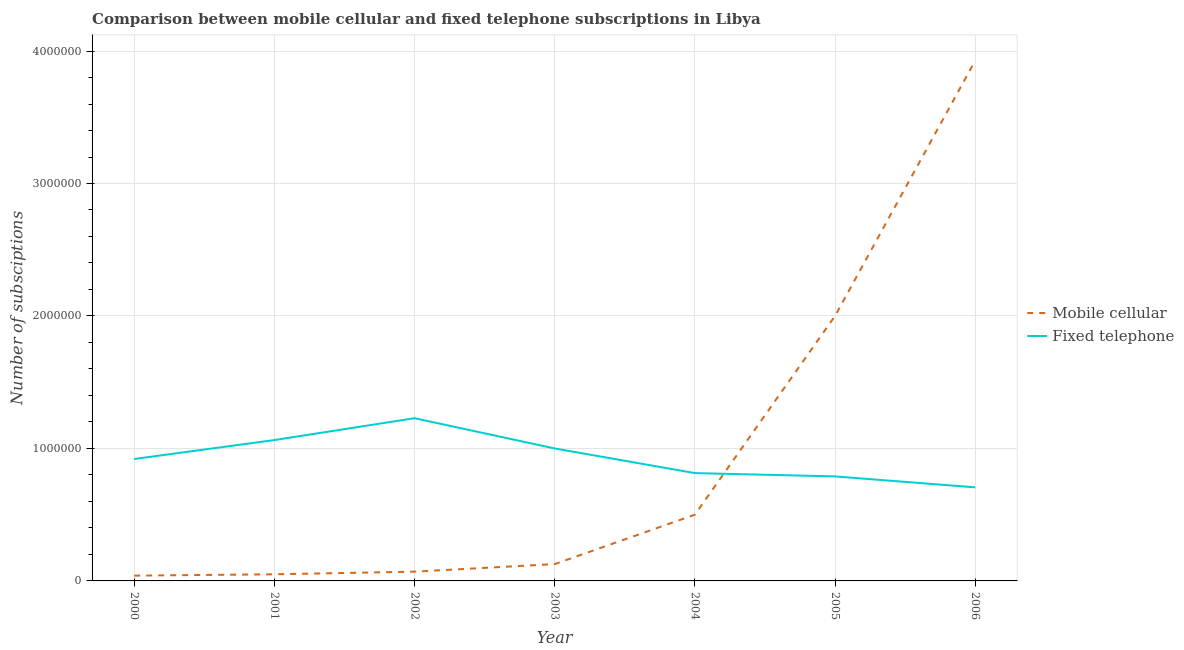What is the number of fixed telephone subscriptions in 2000?
Provide a succinct answer. 9.20e+05. Across all years, what is the maximum number of fixed telephone subscriptions?
Give a very brief answer. 1.23e+06. Across all years, what is the minimum number of fixed telephone subscriptions?
Make the answer very short. 7.06e+05. In which year was the number of fixed telephone subscriptions maximum?
Offer a terse response. 2002. In which year was the number of fixed telephone subscriptions minimum?
Make the answer very short. 2006. What is the total number of mobile cellular subscriptions in the graph?
Make the answer very short. 6.71e+06. What is the difference between the number of mobile cellular subscriptions in 2001 and that in 2004?
Make the answer very short. -4.50e+05. What is the difference between the number of fixed telephone subscriptions in 2004 and the number of mobile cellular subscriptions in 2000?
Offer a terse response. 7.74e+05. What is the average number of fixed telephone subscriptions per year?
Make the answer very short. 9.32e+05. In the year 2002, what is the difference between the number of fixed telephone subscriptions and number of mobile cellular subscriptions?
Your answer should be very brief. 1.16e+06. What is the ratio of the number of mobile cellular subscriptions in 2000 to that in 2002?
Keep it short and to the point. 0.57. What is the difference between the highest and the second highest number of mobile cellular subscriptions?
Provide a succinct answer. 1.93e+06. What is the difference between the highest and the lowest number of mobile cellular subscriptions?
Provide a succinct answer. 3.89e+06. Is the sum of the number of fixed telephone subscriptions in 2005 and 2006 greater than the maximum number of mobile cellular subscriptions across all years?
Keep it short and to the point. No. Is the number of mobile cellular subscriptions strictly less than the number of fixed telephone subscriptions over the years?
Your response must be concise. No. What is the difference between two consecutive major ticks on the Y-axis?
Ensure brevity in your answer.  1.00e+06. Are the values on the major ticks of Y-axis written in scientific E-notation?
Provide a short and direct response. No. Where does the legend appear in the graph?
Make the answer very short. Center right. How are the legend labels stacked?
Give a very brief answer. Vertical. What is the title of the graph?
Offer a terse response. Comparison between mobile cellular and fixed telephone subscriptions in Libya. What is the label or title of the Y-axis?
Ensure brevity in your answer.  Number of subsciptions. What is the Number of subsciptions of Mobile cellular in 2000?
Ensure brevity in your answer.  4.00e+04. What is the Number of subsciptions in Fixed telephone in 2000?
Provide a succinct answer. 9.20e+05. What is the Number of subsciptions of Fixed telephone in 2001?
Keep it short and to the point. 1.06e+06. What is the Number of subsciptions of Fixed telephone in 2002?
Provide a short and direct response. 1.23e+06. What is the Number of subsciptions in Mobile cellular in 2003?
Offer a terse response. 1.27e+05. What is the Number of subsciptions of Fixed telephone in 2003?
Your answer should be compact. 1.00e+06. What is the Number of subsciptions of Fixed telephone in 2004?
Provide a short and direct response. 8.14e+05. What is the Number of subsciptions in Fixed telephone in 2005?
Your answer should be very brief. 7.89e+05. What is the Number of subsciptions in Mobile cellular in 2006?
Ensure brevity in your answer.  3.93e+06. What is the Number of subsciptions of Fixed telephone in 2006?
Keep it short and to the point. 7.06e+05. Across all years, what is the maximum Number of subsciptions in Mobile cellular?
Your answer should be compact. 3.93e+06. Across all years, what is the maximum Number of subsciptions of Fixed telephone?
Keep it short and to the point. 1.23e+06. Across all years, what is the minimum Number of subsciptions of Fixed telephone?
Provide a succinct answer. 7.06e+05. What is the total Number of subsciptions in Mobile cellular in the graph?
Give a very brief answer. 6.71e+06. What is the total Number of subsciptions in Fixed telephone in the graph?
Ensure brevity in your answer.  6.52e+06. What is the difference between the Number of subsciptions of Mobile cellular in 2000 and that in 2001?
Make the answer very short. -10000. What is the difference between the Number of subsciptions in Fixed telephone in 2000 and that in 2001?
Keep it short and to the point. -1.43e+05. What is the difference between the Number of subsciptions of Fixed telephone in 2000 and that in 2002?
Offer a very short reply. -3.08e+05. What is the difference between the Number of subsciptions in Mobile cellular in 2000 and that in 2003?
Offer a terse response. -8.70e+04. What is the difference between the Number of subsciptions of Fixed telephone in 2000 and that in 2003?
Offer a terse response. -7.96e+04. What is the difference between the Number of subsciptions of Mobile cellular in 2000 and that in 2004?
Offer a very short reply. -4.60e+05. What is the difference between the Number of subsciptions of Fixed telephone in 2000 and that in 2004?
Ensure brevity in your answer.  1.06e+05. What is the difference between the Number of subsciptions in Mobile cellular in 2000 and that in 2005?
Provide a short and direct response. -1.96e+06. What is the difference between the Number of subsciptions of Fixed telephone in 2000 and that in 2005?
Offer a terse response. 1.31e+05. What is the difference between the Number of subsciptions in Mobile cellular in 2000 and that in 2006?
Provide a short and direct response. -3.89e+06. What is the difference between the Number of subsciptions in Fixed telephone in 2000 and that in 2006?
Offer a very short reply. 2.14e+05. What is the difference between the Number of subsciptions of Mobile cellular in 2001 and that in 2002?
Ensure brevity in your answer.  -2.00e+04. What is the difference between the Number of subsciptions in Fixed telephone in 2001 and that in 2002?
Offer a terse response. -1.65e+05. What is the difference between the Number of subsciptions in Mobile cellular in 2001 and that in 2003?
Your response must be concise. -7.70e+04. What is the difference between the Number of subsciptions of Fixed telephone in 2001 and that in 2003?
Offer a terse response. 6.33e+04. What is the difference between the Number of subsciptions in Mobile cellular in 2001 and that in 2004?
Your response must be concise. -4.50e+05. What is the difference between the Number of subsciptions of Fixed telephone in 2001 and that in 2004?
Your response must be concise. 2.49e+05. What is the difference between the Number of subsciptions in Mobile cellular in 2001 and that in 2005?
Keep it short and to the point. -1.95e+06. What is the difference between the Number of subsciptions of Fixed telephone in 2001 and that in 2005?
Keep it short and to the point. 2.74e+05. What is the difference between the Number of subsciptions in Mobile cellular in 2001 and that in 2006?
Offer a terse response. -3.88e+06. What is the difference between the Number of subsciptions in Fixed telephone in 2001 and that in 2006?
Provide a short and direct response. 3.57e+05. What is the difference between the Number of subsciptions in Mobile cellular in 2002 and that in 2003?
Provide a short and direct response. -5.70e+04. What is the difference between the Number of subsciptions in Fixed telephone in 2002 and that in 2003?
Provide a short and direct response. 2.28e+05. What is the difference between the Number of subsciptions of Mobile cellular in 2002 and that in 2004?
Ensure brevity in your answer.  -4.30e+05. What is the difference between the Number of subsciptions in Fixed telephone in 2002 and that in 2004?
Give a very brief answer. 4.14e+05. What is the difference between the Number of subsciptions of Mobile cellular in 2002 and that in 2005?
Your response must be concise. -1.93e+06. What is the difference between the Number of subsciptions of Fixed telephone in 2002 and that in 2005?
Keep it short and to the point. 4.39e+05. What is the difference between the Number of subsciptions of Mobile cellular in 2002 and that in 2006?
Keep it short and to the point. -3.86e+06. What is the difference between the Number of subsciptions in Fixed telephone in 2002 and that in 2006?
Keep it short and to the point. 5.22e+05. What is the difference between the Number of subsciptions of Mobile cellular in 2003 and that in 2004?
Your answer should be very brief. -3.73e+05. What is the difference between the Number of subsciptions of Fixed telephone in 2003 and that in 2004?
Provide a short and direct response. 1.86e+05. What is the difference between the Number of subsciptions of Mobile cellular in 2003 and that in 2005?
Make the answer very short. -1.87e+06. What is the difference between the Number of subsciptions of Fixed telephone in 2003 and that in 2005?
Your response must be concise. 2.11e+05. What is the difference between the Number of subsciptions of Mobile cellular in 2003 and that in 2006?
Your answer should be compact. -3.80e+06. What is the difference between the Number of subsciptions in Fixed telephone in 2003 and that in 2006?
Offer a very short reply. 2.94e+05. What is the difference between the Number of subsciptions of Mobile cellular in 2004 and that in 2005?
Provide a succinct answer. -1.50e+06. What is the difference between the Number of subsciptions of Fixed telephone in 2004 and that in 2005?
Offer a terse response. 2.50e+04. What is the difference between the Number of subsciptions in Mobile cellular in 2004 and that in 2006?
Keep it short and to the point. -3.43e+06. What is the difference between the Number of subsciptions in Fixed telephone in 2004 and that in 2006?
Your answer should be very brief. 1.08e+05. What is the difference between the Number of subsciptions of Mobile cellular in 2005 and that in 2006?
Make the answer very short. -1.93e+06. What is the difference between the Number of subsciptions of Fixed telephone in 2005 and that in 2006?
Keep it short and to the point. 8.26e+04. What is the difference between the Number of subsciptions in Mobile cellular in 2000 and the Number of subsciptions in Fixed telephone in 2001?
Offer a very short reply. -1.02e+06. What is the difference between the Number of subsciptions in Mobile cellular in 2000 and the Number of subsciptions in Fixed telephone in 2002?
Provide a short and direct response. -1.19e+06. What is the difference between the Number of subsciptions of Mobile cellular in 2000 and the Number of subsciptions of Fixed telephone in 2003?
Offer a terse response. -9.60e+05. What is the difference between the Number of subsciptions of Mobile cellular in 2000 and the Number of subsciptions of Fixed telephone in 2004?
Your answer should be very brief. -7.74e+05. What is the difference between the Number of subsciptions of Mobile cellular in 2000 and the Number of subsciptions of Fixed telephone in 2005?
Provide a succinct answer. -7.49e+05. What is the difference between the Number of subsciptions of Mobile cellular in 2000 and the Number of subsciptions of Fixed telephone in 2006?
Your answer should be compact. -6.66e+05. What is the difference between the Number of subsciptions of Mobile cellular in 2001 and the Number of subsciptions of Fixed telephone in 2002?
Provide a short and direct response. -1.18e+06. What is the difference between the Number of subsciptions of Mobile cellular in 2001 and the Number of subsciptions of Fixed telephone in 2003?
Your answer should be very brief. -9.50e+05. What is the difference between the Number of subsciptions of Mobile cellular in 2001 and the Number of subsciptions of Fixed telephone in 2004?
Keep it short and to the point. -7.64e+05. What is the difference between the Number of subsciptions in Mobile cellular in 2001 and the Number of subsciptions in Fixed telephone in 2005?
Offer a very short reply. -7.39e+05. What is the difference between the Number of subsciptions of Mobile cellular in 2001 and the Number of subsciptions of Fixed telephone in 2006?
Ensure brevity in your answer.  -6.56e+05. What is the difference between the Number of subsciptions in Mobile cellular in 2002 and the Number of subsciptions in Fixed telephone in 2003?
Your answer should be compact. -9.30e+05. What is the difference between the Number of subsciptions of Mobile cellular in 2002 and the Number of subsciptions of Fixed telephone in 2004?
Make the answer very short. -7.44e+05. What is the difference between the Number of subsciptions in Mobile cellular in 2002 and the Number of subsciptions in Fixed telephone in 2005?
Offer a terse response. -7.19e+05. What is the difference between the Number of subsciptions in Mobile cellular in 2002 and the Number of subsciptions in Fixed telephone in 2006?
Give a very brief answer. -6.36e+05. What is the difference between the Number of subsciptions of Mobile cellular in 2003 and the Number of subsciptions of Fixed telephone in 2004?
Provide a succinct answer. -6.87e+05. What is the difference between the Number of subsciptions of Mobile cellular in 2003 and the Number of subsciptions of Fixed telephone in 2005?
Make the answer very short. -6.62e+05. What is the difference between the Number of subsciptions of Mobile cellular in 2003 and the Number of subsciptions of Fixed telephone in 2006?
Keep it short and to the point. -5.79e+05. What is the difference between the Number of subsciptions in Mobile cellular in 2004 and the Number of subsciptions in Fixed telephone in 2005?
Provide a short and direct response. -2.89e+05. What is the difference between the Number of subsciptions of Mobile cellular in 2004 and the Number of subsciptions of Fixed telephone in 2006?
Your response must be concise. -2.06e+05. What is the difference between the Number of subsciptions in Mobile cellular in 2005 and the Number of subsciptions in Fixed telephone in 2006?
Provide a succinct answer. 1.29e+06. What is the average Number of subsciptions of Mobile cellular per year?
Provide a succinct answer. 9.59e+05. What is the average Number of subsciptions in Fixed telephone per year?
Give a very brief answer. 9.32e+05. In the year 2000, what is the difference between the Number of subsciptions of Mobile cellular and Number of subsciptions of Fixed telephone?
Make the answer very short. -8.80e+05. In the year 2001, what is the difference between the Number of subsciptions of Mobile cellular and Number of subsciptions of Fixed telephone?
Make the answer very short. -1.01e+06. In the year 2002, what is the difference between the Number of subsciptions of Mobile cellular and Number of subsciptions of Fixed telephone?
Ensure brevity in your answer.  -1.16e+06. In the year 2003, what is the difference between the Number of subsciptions of Mobile cellular and Number of subsciptions of Fixed telephone?
Provide a succinct answer. -8.73e+05. In the year 2004, what is the difference between the Number of subsciptions in Mobile cellular and Number of subsciptions in Fixed telephone?
Ensure brevity in your answer.  -3.14e+05. In the year 2005, what is the difference between the Number of subsciptions in Mobile cellular and Number of subsciptions in Fixed telephone?
Provide a short and direct response. 1.21e+06. In the year 2006, what is the difference between the Number of subsciptions in Mobile cellular and Number of subsciptions in Fixed telephone?
Your answer should be very brief. 3.22e+06. What is the ratio of the Number of subsciptions of Mobile cellular in 2000 to that in 2001?
Ensure brevity in your answer.  0.8. What is the ratio of the Number of subsciptions in Fixed telephone in 2000 to that in 2001?
Ensure brevity in your answer.  0.87. What is the ratio of the Number of subsciptions in Fixed telephone in 2000 to that in 2002?
Offer a very short reply. 0.75. What is the ratio of the Number of subsciptions in Mobile cellular in 2000 to that in 2003?
Offer a terse response. 0.32. What is the ratio of the Number of subsciptions of Fixed telephone in 2000 to that in 2003?
Make the answer very short. 0.92. What is the ratio of the Number of subsciptions of Mobile cellular in 2000 to that in 2004?
Ensure brevity in your answer.  0.08. What is the ratio of the Number of subsciptions in Fixed telephone in 2000 to that in 2004?
Keep it short and to the point. 1.13. What is the ratio of the Number of subsciptions in Fixed telephone in 2000 to that in 2005?
Give a very brief answer. 1.17. What is the ratio of the Number of subsciptions of Mobile cellular in 2000 to that in 2006?
Provide a succinct answer. 0.01. What is the ratio of the Number of subsciptions in Fixed telephone in 2000 to that in 2006?
Ensure brevity in your answer.  1.3. What is the ratio of the Number of subsciptions of Mobile cellular in 2001 to that in 2002?
Provide a short and direct response. 0.71. What is the ratio of the Number of subsciptions in Fixed telephone in 2001 to that in 2002?
Make the answer very short. 0.87. What is the ratio of the Number of subsciptions in Mobile cellular in 2001 to that in 2003?
Provide a short and direct response. 0.39. What is the ratio of the Number of subsciptions in Fixed telephone in 2001 to that in 2003?
Give a very brief answer. 1.06. What is the ratio of the Number of subsciptions in Mobile cellular in 2001 to that in 2004?
Offer a terse response. 0.1. What is the ratio of the Number of subsciptions of Fixed telephone in 2001 to that in 2004?
Your answer should be very brief. 1.31. What is the ratio of the Number of subsciptions in Mobile cellular in 2001 to that in 2005?
Keep it short and to the point. 0.03. What is the ratio of the Number of subsciptions of Fixed telephone in 2001 to that in 2005?
Make the answer very short. 1.35. What is the ratio of the Number of subsciptions in Mobile cellular in 2001 to that in 2006?
Ensure brevity in your answer.  0.01. What is the ratio of the Number of subsciptions of Fixed telephone in 2001 to that in 2006?
Offer a very short reply. 1.51. What is the ratio of the Number of subsciptions of Mobile cellular in 2002 to that in 2003?
Give a very brief answer. 0.55. What is the ratio of the Number of subsciptions of Fixed telephone in 2002 to that in 2003?
Ensure brevity in your answer.  1.23. What is the ratio of the Number of subsciptions in Mobile cellular in 2002 to that in 2004?
Offer a very short reply. 0.14. What is the ratio of the Number of subsciptions in Fixed telephone in 2002 to that in 2004?
Give a very brief answer. 1.51. What is the ratio of the Number of subsciptions of Mobile cellular in 2002 to that in 2005?
Your response must be concise. 0.04. What is the ratio of the Number of subsciptions in Fixed telephone in 2002 to that in 2005?
Ensure brevity in your answer.  1.56. What is the ratio of the Number of subsciptions in Mobile cellular in 2002 to that in 2006?
Offer a very short reply. 0.02. What is the ratio of the Number of subsciptions of Fixed telephone in 2002 to that in 2006?
Provide a short and direct response. 1.74. What is the ratio of the Number of subsciptions in Mobile cellular in 2003 to that in 2004?
Your answer should be compact. 0.25. What is the ratio of the Number of subsciptions in Fixed telephone in 2003 to that in 2004?
Give a very brief answer. 1.23. What is the ratio of the Number of subsciptions of Mobile cellular in 2003 to that in 2005?
Your answer should be compact. 0.06. What is the ratio of the Number of subsciptions in Fixed telephone in 2003 to that in 2005?
Make the answer very short. 1.27. What is the ratio of the Number of subsciptions in Mobile cellular in 2003 to that in 2006?
Keep it short and to the point. 0.03. What is the ratio of the Number of subsciptions in Fixed telephone in 2003 to that in 2006?
Make the answer very short. 1.42. What is the ratio of the Number of subsciptions in Mobile cellular in 2004 to that in 2005?
Ensure brevity in your answer.  0.25. What is the ratio of the Number of subsciptions in Fixed telephone in 2004 to that in 2005?
Make the answer very short. 1.03. What is the ratio of the Number of subsciptions of Mobile cellular in 2004 to that in 2006?
Provide a succinct answer. 0.13. What is the ratio of the Number of subsciptions in Fixed telephone in 2004 to that in 2006?
Offer a terse response. 1.15. What is the ratio of the Number of subsciptions in Mobile cellular in 2005 to that in 2006?
Offer a terse response. 0.51. What is the ratio of the Number of subsciptions of Fixed telephone in 2005 to that in 2006?
Provide a succinct answer. 1.12. What is the difference between the highest and the second highest Number of subsciptions in Mobile cellular?
Keep it short and to the point. 1.93e+06. What is the difference between the highest and the second highest Number of subsciptions in Fixed telephone?
Your answer should be very brief. 1.65e+05. What is the difference between the highest and the lowest Number of subsciptions in Mobile cellular?
Your response must be concise. 3.89e+06. What is the difference between the highest and the lowest Number of subsciptions of Fixed telephone?
Give a very brief answer. 5.22e+05. 